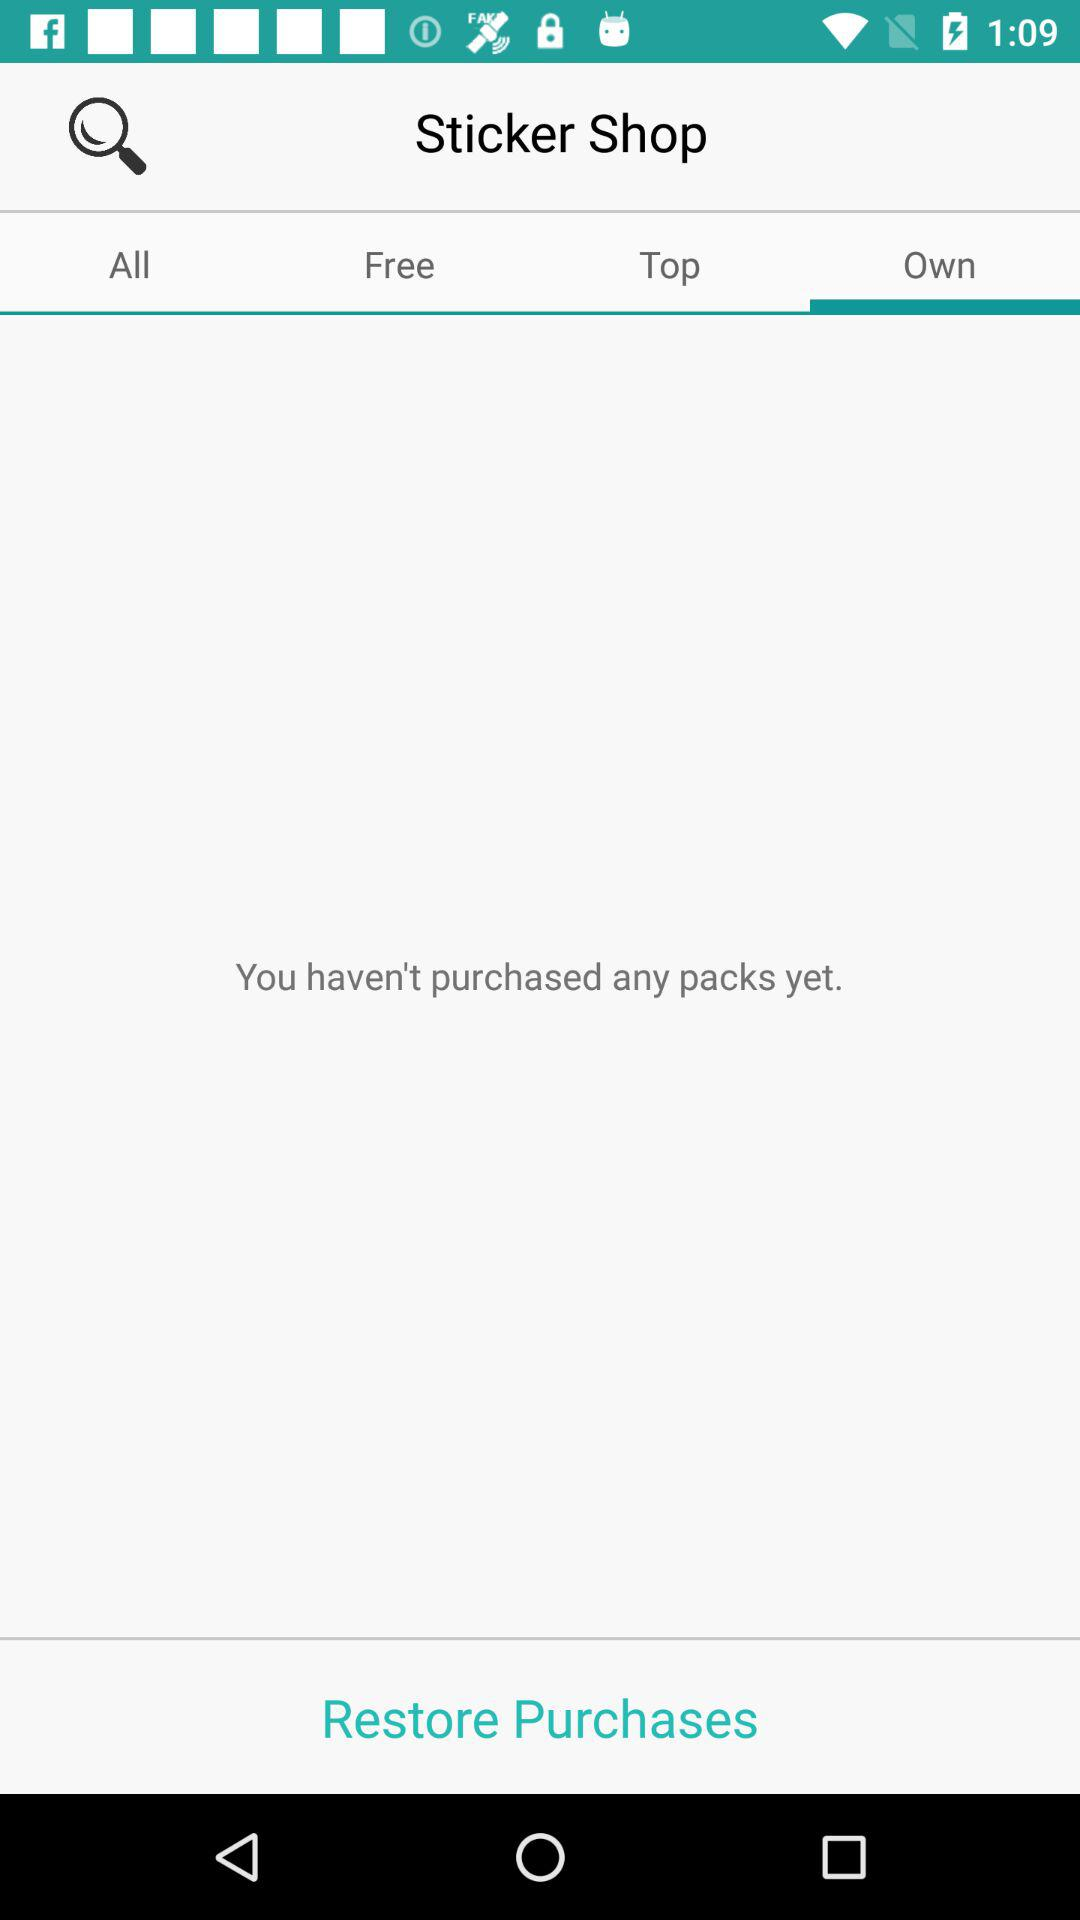Is there any purchase? There is no purchase. 